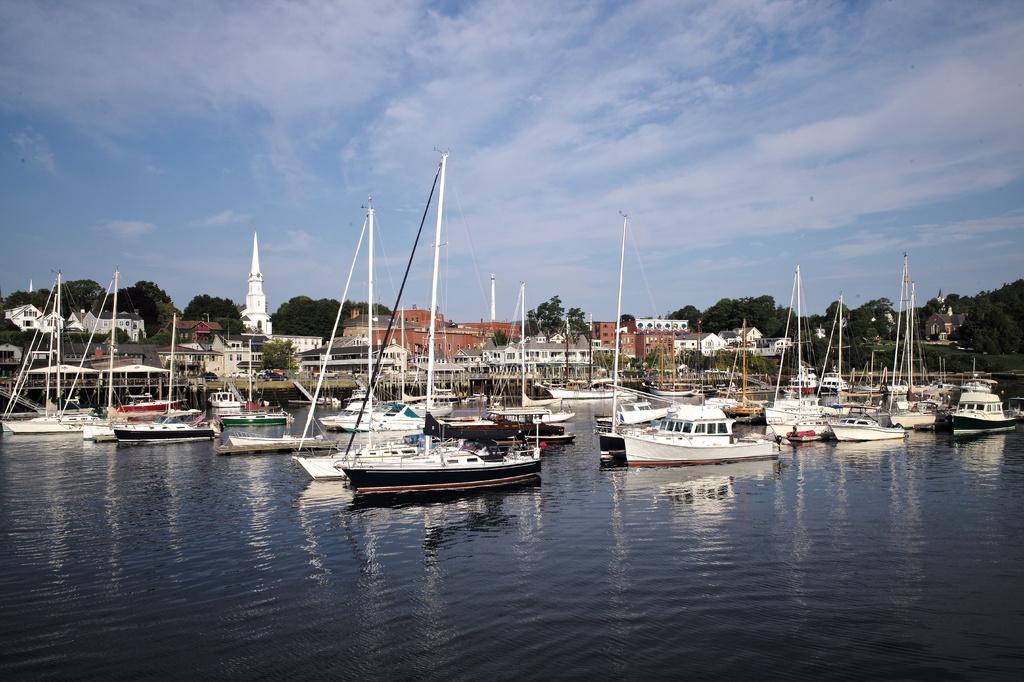How would you summarize this image in a sentence or two? In this image we can see ships and boats on the water, buildings, trees and sky with clouds. 